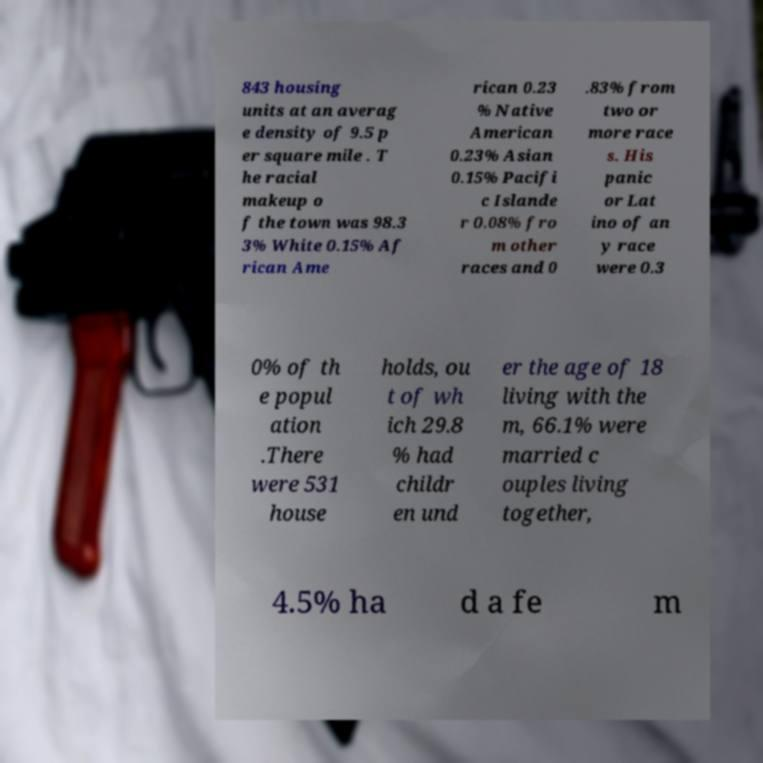Please identify and transcribe the text found in this image. 843 housing units at an averag e density of 9.5 p er square mile . T he racial makeup o f the town was 98.3 3% White 0.15% Af rican Ame rican 0.23 % Native American 0.23% Asian 0.15% Pacifi c Islande r 0.08% fro m other races and 0 .83% from two or more race s. His panic or Lat ino of an y race were 0.3 0% of th e popul ation .There were 531 house holds, ou t of wh ich 29.8 % had childr en und er the age of 18 living with the m, 66.1% were married c ouples living together, 4.5% ha d a fe m 